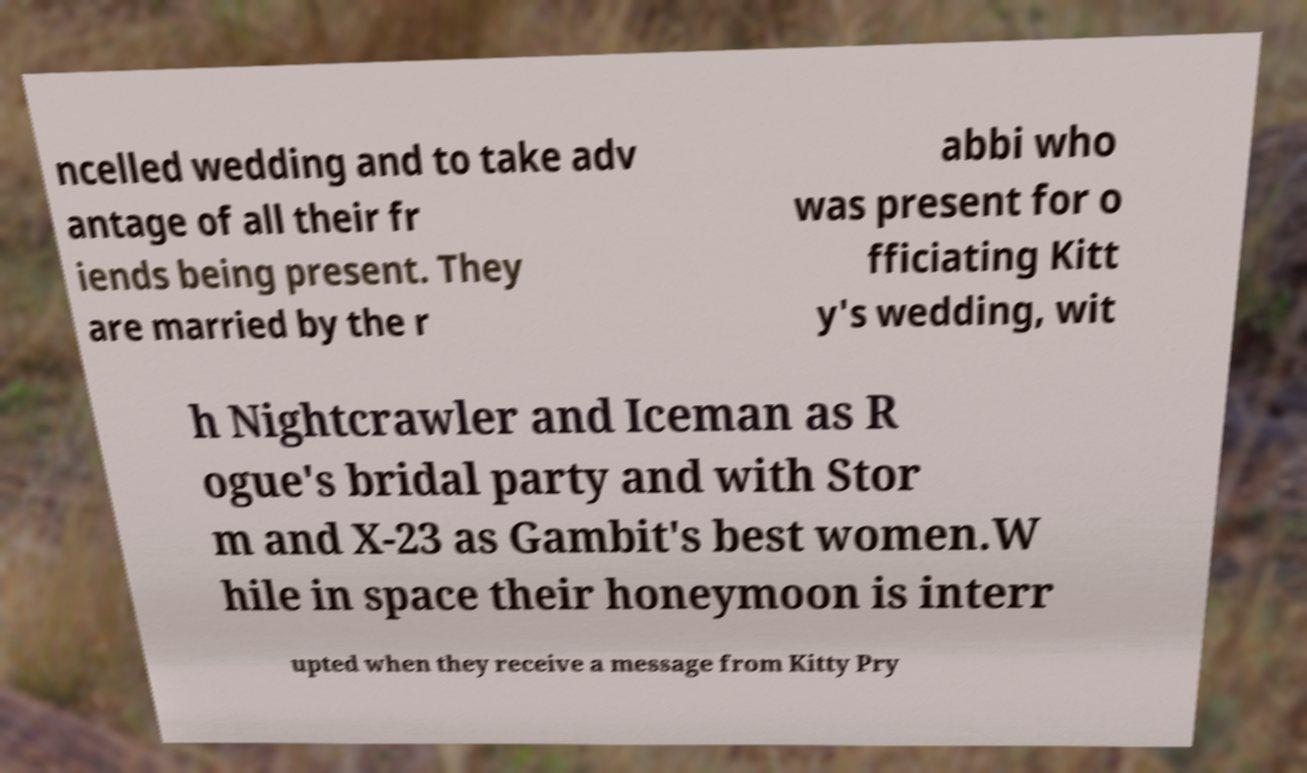Can you accurately transcribe the text from the provided image for me? ncelled wedding and to take adv antage of all their fr iends being present. They are married by the r abbi who was present for o fficiating Kitt y's wedding, wit h Nightcrawler and Iceman as R ogue's bridal party and with Stor m and X-23 as Gambit's best women.W hile in space their honeymoon is interr upted when they receive a message from Kitty Pry 